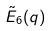Convert formula to latex. <formula><loc_0><loc_0><loc_500><loc_500>\tilde { E } _ { 6 } ( q )</formula> 